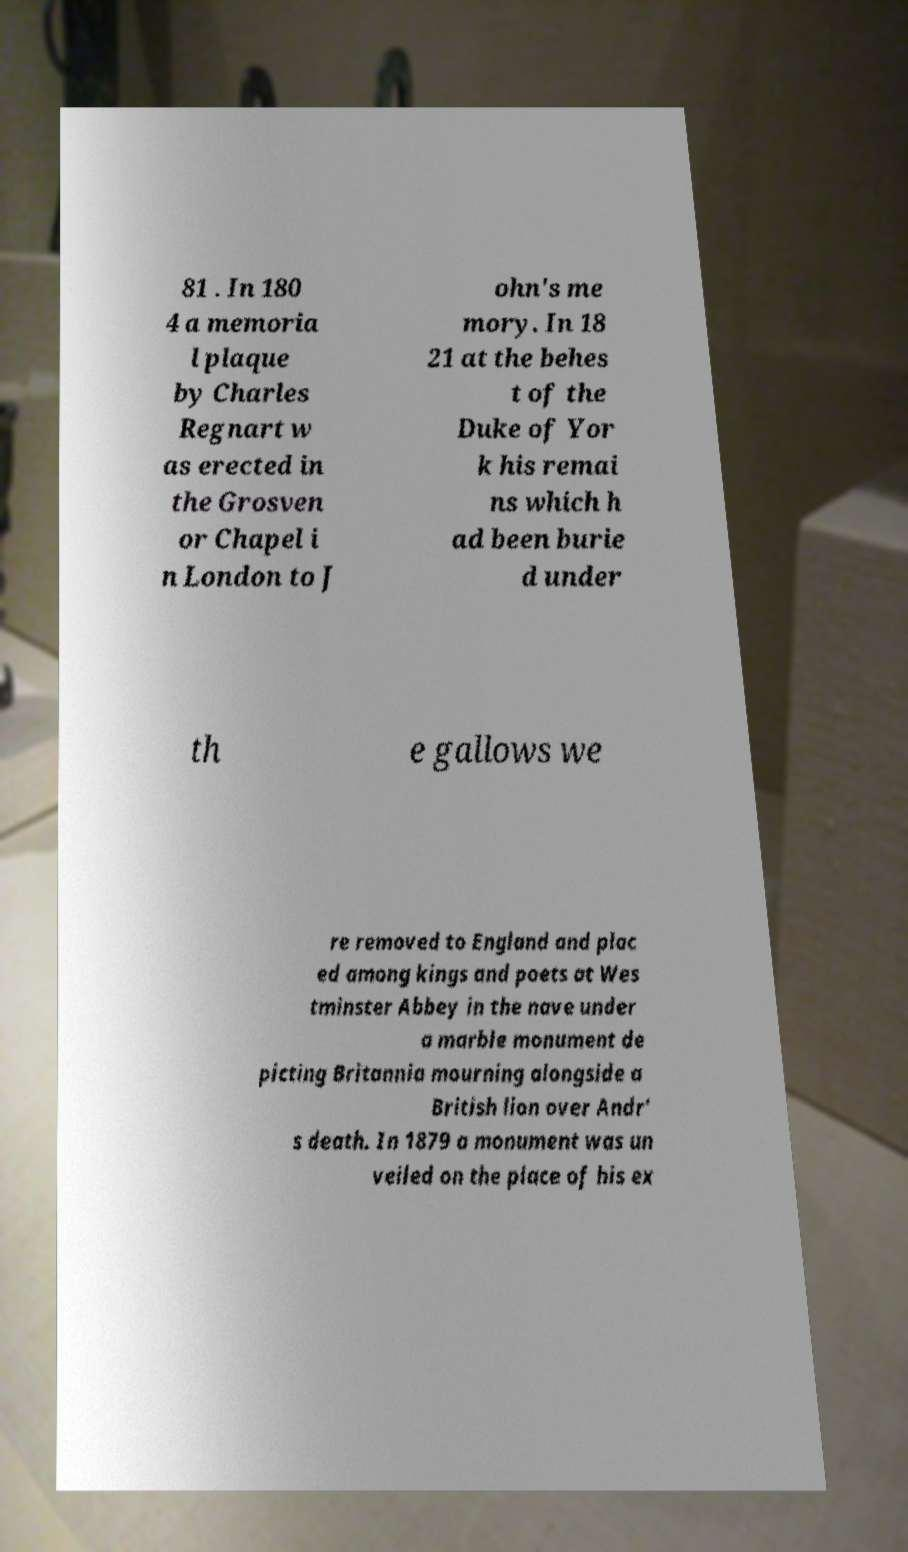For documentation purposes, I need the text within this image transcribed. Could you provide that? 81 . In 180 4 a memoria l plaque by Charles Regnart w as erected in the Grosven or Chapel i n London to J ohn's me mory. In 18 21 at the behes t of the Duke of Yor k his remai ns which h ad been burie d under th e gallows we re removed to England and plac ed among kings and poets at Wes tminster Abbey in the nave under a marble monument de picting Britannia mourning alongside a British lion over Andr' s death. In 1879 a monument was un veiled on the place of his ex 